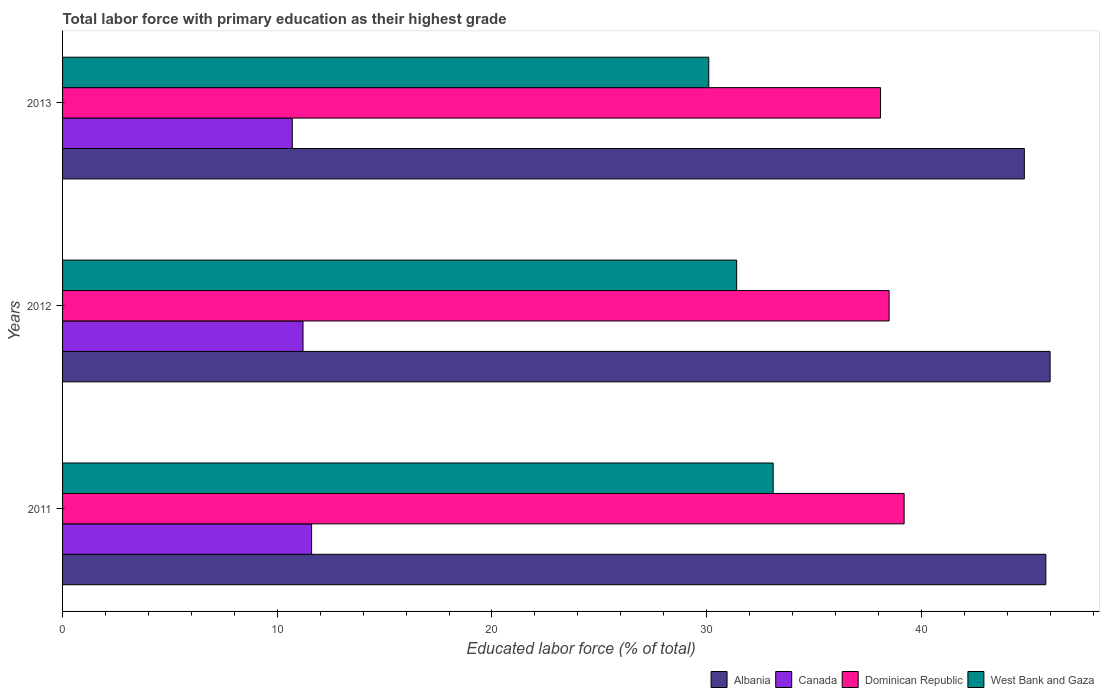How many different coloured bars are there?
Make the answer very short. 4. How many bars are there on the 1st tick from the top?
Your answer should be very brief. 4. What is the percentage of total labor force with primary education in Dominican Republic in 2011?
Offer a terse response. 39.2. Across all years, what is the minimum percentage of total labor force with primary education in Dominican Republic?
Your answer should be very brief. 38.1. In which year was the percentage of total labor force with primary education in West Bank and Gaza maximum?
Provide a short and direct response. 2011. In which year was the percentage of total labor force with primary education in Dominican Republic minimum?
Your answer should be compact. 2013. What is the total percentage of total labor force with primary education in West Bank and Gaza in the graph?
Your response must be concise. 94.6. What is the difference between the percentage of total labor force with primary education in Albania in 2011 and that in 2013?
Offer a terse response. 1. What is the difference between the percentage of total labor force with primary education in Canada in 2011 and the percentage of total labor force with primary education in Dominican Republic in 2013?
Provide a short and direct response. -26.5. What is the average percentage of total labor force with primary education in West Bank and Gaza per year?
Make the answer very short. 31.53. What is the ratio of the percentage of total labor force with primary education in West Bank and Gaza in 2011 to that in 2012?
Ensure brevity in your answer.  1.05. What is the difference between the highest and the second highest percentage of total labor force with primary education in West Bank and Gaza?
Provide a succinct answer. 1.7. What is the difference between the highest and the lowest percentage of total labor force with primary education in West Bank and Gaza?
Give a very brief answer. 3. In how many years, is the percentage of total labor force with primary education in Canada greater than the average percentage of total labor force with primary education in Canada taken over all years?
Your answer should be very brief. 2. Is it the case that in every year, the sum of the percentage of total labor force with primary education in Dominican Republic and percentage of total labor force with primary education in Canada is greater than the sum of percentage of total labor force with primary education in Albania and percentage of total labor force with primary education in West Bank and Gaza?
Offer a very short reply. No. What does the 1st bar from the top in 2012 represents?
Make the answer very short. West Bank and Gaza. What does the 1st bar from the bottom in 2013 represents?
Keep it short and to the point. Albania. Is it the case that in every year, the sum of the percentage of total labor force with primary education in Dominican Republic and percentage of total labor force with primary education in West Bank and Gaza is greater than the percentage of total labor force with primary education in Canada?
Your answer should be compact. Yes. Are all the bars in the graph horizontal?
Provide a succinct answer. Yes. How many years are there in the graph?
Offer a terse response. 3. What is the difference between two consecutive major ticks on the X-axis?
Your answer should be compact. 10. Are the values on the major ticks of X-axis written in scientific E-notation?
Your answer should be compact. No. Does the graph contain any zero values?
Ensure brevity in your answer.  No. Where does the legend appear in the graph?
Ensure brevity in your answer.  Bottom right. How are the legend labels stacked?
Give a very brief answer. Horizontal. What is the title of the graph?
Provide a succinct answer. Total labor force with primary education as their highest grade. What is the label or title of the X-axis?
Your answer should be very brief. Educated labor force (% of total). What is the label or title of the Y-axis?
Give a very brief answer. Years. What is the Educated labor force (% of total) of Albania in 2011?
Your response must be concise. 45.8. What is the Educated labor force (% of total) of Canada in 2011?
Your answer should be very brief. 11.6. What is the Educated labor force (% of total) of Dominican Republic in 2011?
Offer a very short reply. 39.2. What is the Educated labor force (% of total) of West Bank and Gaza in 2011?
Provide a succinct answer. 33.1. What is the Educated labor force (% of total) in Canada in 2012?
Provide a short and direct response. 11.2. What is the Educated labor force (% of total) in Dominican Republic in 2012?
Provide a succinct answer. 38.5. What is the Educated labor force (% of total) in West Bank and Gaza in 2012?
Provide a short and direct response. 31.4. What is the Educated labor force (% of total) in Albania in 2013?
Give a very brief answer. 44.8. What is the Educated labor force (% of total) in Canada in 2013?
Make the answer very short. 10.7. What is the Educated labor force (% of total) in Dominican Republic in 2013?
Offer a very short reply. 38.1. What is the Educated labor force (% of total) in West Bank and Gaza in 2013?
Your answer should be compact. 30.1. Across all years, what is the maximum Educated labor force (% of total) of Canada?
Provide a short and direct response. 11.6. Across all years, what is the maximum Educated labor force (% of total) in Dominican Republic?
Make the answer very short. 39.2. Across all years, what is the maximum Educated labor force (% of total) of West Bank and Gaza?
Your answer should be compact. 33.1. Across all years, what is the minimum Educated labor force (% of total) in Albania?
Ensure brevity in your answer.  44.8. Across all years, what is the minimum Educated labor force (% of total) of Canada?
Make the answer very short. 10.7. Across all years, what is the minimum Educated labor force (% of total) in Dominican Republic?
Your answer should be very brief. 38.1. Across all years, what is the minimum Educated labor force (% of total) of West Bank and Gaza?
Ensure brevity in your answer.  30.1. What is the total Educated labor force (% of total) of Albania in the graph?
Provide a succinct answer. 136.6. What is the total Educated labor force (% of total) in Canada in the graph?
Provide a short and direct response. 33.5. What is the total Educated labor force (% of total) of Dominican Republic in the graph?
Keep it short and to the point. 115.8. What is the total Educated labor force (% of total) of West Bank and Gaza in the graph?
Your answer should be compact. 94.6. What is the difference between the Educated labor force (% of total) of Dominican Republic in 2011 and that in 2013?
Make the answer very short. 1.1. What is the difference between the Educated labor force (% of total) in West Bank and Gaza in 2011 and that in 2013?
Give a very brief answer. 3. What is the difference between the Educated labor force (% of total) in Canada in 2012 and that in 2013?
Offer a terse response. 0.5. What is the difference between the Educated labor force (% of total) in Albania in 2011 and the Educated labor force (% of total) in Canada in 2012?
Provide a short and direct response. 34.6. What is the difference between the Educated labor force (% of total) of Albania in 2011 and the Educated labor force (% of total) of West Bank and Gaza in 2012?
Give a very brief answer. 14.4. What is the difference between the Educated labor force (% of total) of Canada in 2011 and the Educated labor force (% of total) of Dominican Republic in 2012?
Give a very brief answer. -26.9. What is the difference between the Educated labor force (% of total) of Canada in 2011 and the Educated labor force (% of total) of West Bank and Gaza in 2012?
Provide a short and direct response. -19.8. What is the difference between the Educated labor force (% of total) of Dominican Republic in 2011 and the Educated labor force (% of total) of West Bank and Gaza in 2012?
Make the answer very short. 7.8. What is the difference between the Educated labor force (% of total) of Albania in 2011 and the Educated labor force (% of total) of Canada in 2013?
Make the answer very short. 35.1. What is the difference between the Educated labor force (% of total) in Albania in 2011 and the Educated labor force (% of total) in Dominican Republic in 2013?
Provide a succinct answer. 7.7. What is the difference between the Educated labor force (% of total) of Canada in 2011 and the Educated labor force (% of total) of Dominican Republic in 2013?
Offer a terse response. -26.5. What is the difference between the Educated labor force (% of total) of Canada in 2011 and the Educated labor force (% of total) of West Bank and Gaza in 2013?
Your answer should be compact. -18.5. What is the difference between the Educated labor force (% of total) in Dominican Republic in 2011 and the Educated labor force (% of total) in West Bank and Gaza in 2013?
Offer a very short reply. 9.1. What is the difference between the Educated labor force (% of total) of Albania in 2012 and the Educated labor force (% of total) of Canada in 2013?
Your response must be concise. 35.3. What is the difference between the Educated labor force (% of total) of Albania in 2012 and the Educated labor force (% of total) of Dominican Republic in 2013?
Offer a terse response. 7.9. What is the difference between the Educated labor force (% of total) in Albania in 2012 and the Educated labor force (% of total) in West Bank and Gaza in 2013?
Give a very brief answer. 15.9. What is the difference between the Educated labor force (% of total) in Canada in 2012 and the Educated labor force (% of total) in Dominican Republic in 2013?
Your response must be concise. -26.9. What is the difference between the Educated labor force (% of total) in Canada in 2012 and the Educated labor force (% of total) in West Bank and Gaza in 2013?
Offer a terse response. -18.9. What is the difference between the Educated labor force (% of total) of Dominican Republic in 2012 and the Educated labor force (% of total) of West Bank and Gaza in 2013?
Your answer should be compact. 8.4. What is the average Educated labor force (% of total) in Albania per year?
Your response must be concise. 45.53. What is the average Educated labor force (% of total) in Canada per year?
Your answer should be compact. 11.17. What is the average Educated labor force (% of total) in Dominican Republic per year?
Offer a very short reply. 38.6. What is the average Educated labor force (% of total) of West Bank and Gaza per year?
Give a very brief answer. 31.53. In the year 2011, what is the difference between the Educated labor force (% of total) of Albania and Educated labor force (% of total) of Canada?
Provide a succinct answer. 34.2. In the year 2011, what is the difference between the Educated labor force (% of total) of Albania and Educated labor force (% of total) of Dominican Republic?
Give a very brief answer. 6.6. In the year 2011, what is the difference between the Educated labor force (% of total) in Albania and Educated labor force (% of total) in West Bank and Gaza?
Your answer should be compact. 12.7. In the year 2011, what is the difference between the Educated labor force (% of total) of Canada and Educated labor force (% of total) of Dominican Republic?
Offer a very short reply. -27.6. In the year 2011, what is the difference between the Educated labor force (% of total) of Canada and Educated labor force (% of total) of West Bank and Gaza?
Your response must be concise. -21.5. In the year 2011, what is the difference between the Educated labor force (% of total) of Dominican Republic and Educated labor force (% of total) of West Bank and Gaza?
Offer a very short reply. 6.1. In the year 2012, what is the difference between the Educated labor force (% of total) of Albania and Educated labor force (% of total) of Canada?
Offer a terse response. 34.8. In the year 2012, what is the difference between the Educated labor force (% of total) in Albania and Educated labor force (% of total) in Dominican Republic?
Give a very brief answer. 7.5. In the year 2012, what is the difference between the Educated labor force (% of total) of Canada and Educated labor force (% of total) of Dominican Republic?
Ensure brevity in your answer.  -27.3. In the year 2012, what is the difference between the Educated labor force (% of total) in Canada and Educated labor force (% of total) in West Bank and Gaza?
Your answer should be compact. -20.2. In the year 2012, what is the difference between the Educated labor force (% of total) of Dominican Republic and Educated labor force (% of total) of West Bank and Gaza?
Ensure brevity in your answer.  7.1. In the year 2013, what is the difference between the Educated labor force (% of total) of Albania and Educated labor force (% of total) of Canada?
Make the answer very short. 34.1. In the year 2013, what is the difference between the Educated labor force (% of total) in Albania and Educated labor force (% of total) in Dominican Republic?
Offer a very short reply. 6.7. In the year 2013, what is the difference between the Educated labor force (% of total) of Canada and Educated labor force (% of total) of Dominican Republic?
Ensure brevity in your answer.  -27.4. In the year 2013, what is the difference between the Educated labor force (% of total) of Canada and Educated labor force (% of total) of West Bank and Gaza?
Your answer should be very brief. -19.4. What is the ratio of the Educated labor force (% of total) of Canada in 2011 to that in 2012?
Make the answer very short. 1.04. What is the ratio of the Educated labor force (% of total) in Dominican Republic in 2011 to that in 2012?
Provide a succinct answer. 1.02. What is the ratio of the Educated labor force (% of total) in West Bank and Gaza in 2011 to that in 2012?
Your answer should be compact. 1.05. What is the ratio of the Educated labor force (% of total) of Albania in 2011 to that in 2013?
Offer a very short reply. 1.02. What is the ratio of the Educated labor force (% of total) of Canada in 2011 to that in 2013?
Provide a short and direct response. 1.08. What is the ratio of the Educated labor force (% of total) in Dominican Republic in 2011 to that in 2013?
Make the answer very short. 1.03. What is the ratio of the Educated labor force (% of total) in West Bank and Gaza in 2011 to that in 2013?
Your answer should be compact. 1.1. What is the ratio of the Educated labor force (% of total) of Albania in 2012 to that in 2013?
Your answer should be very brief. 1.03. What is the ratio of the Educated labor force (% of total) in Canada in 2012 to that in 2013?
Keep it short and to the point. 1.05. What is the ratio of the Educated labor force (% of total) in Dominican Republic in 2012 to that in 2013?
Your answer should be compact. 1.01. What is the ratio of the Educated labor force (% of total) of West Bank and Gaza in 2012 to that in 2013?
Offer a very short reply. 1.04. What is the difference between the highest and the second highest Educated labor force (% of total) of Albania?
Ensure brevity in your answer.  0.2. What is the difference between the highest and the second highest Educated labor force (% of total) of Canada?
Make the answer very short. 0.4. What is the difference between the highest and the second highest Educated labor force (% of total) in Dominican Republic?
Give a very brief answer. 0.7. What is the difference between the highest and the second highest Educated labor force (% of total) of West Bank and Gaza?
Offer a terse response. 1.7. What is the difference between the highest and the lowest Educated labor force (% of total) of Dominican Republic?
Your response must be concise. 1.1. 